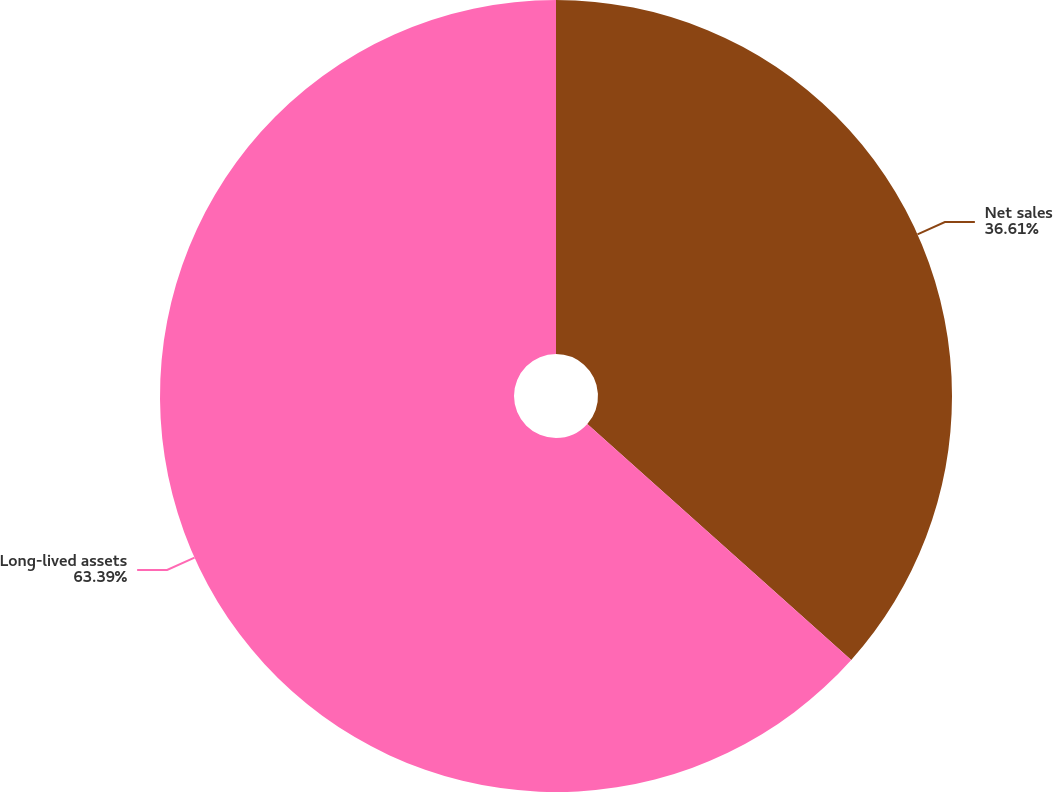Convert chart. <chart><loc_0><loc_0><loc_500><loc_500><pie_chart><fcel>Net sales<fcel>Long-lived assets<nl><fcel>36.61%<fcel>63.39%<nl></chart> 